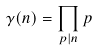<formula> <loc_0><loc_0><loc_500><loc_500>\gamma ( n ) = \prod _ { p | n } p</formula> 